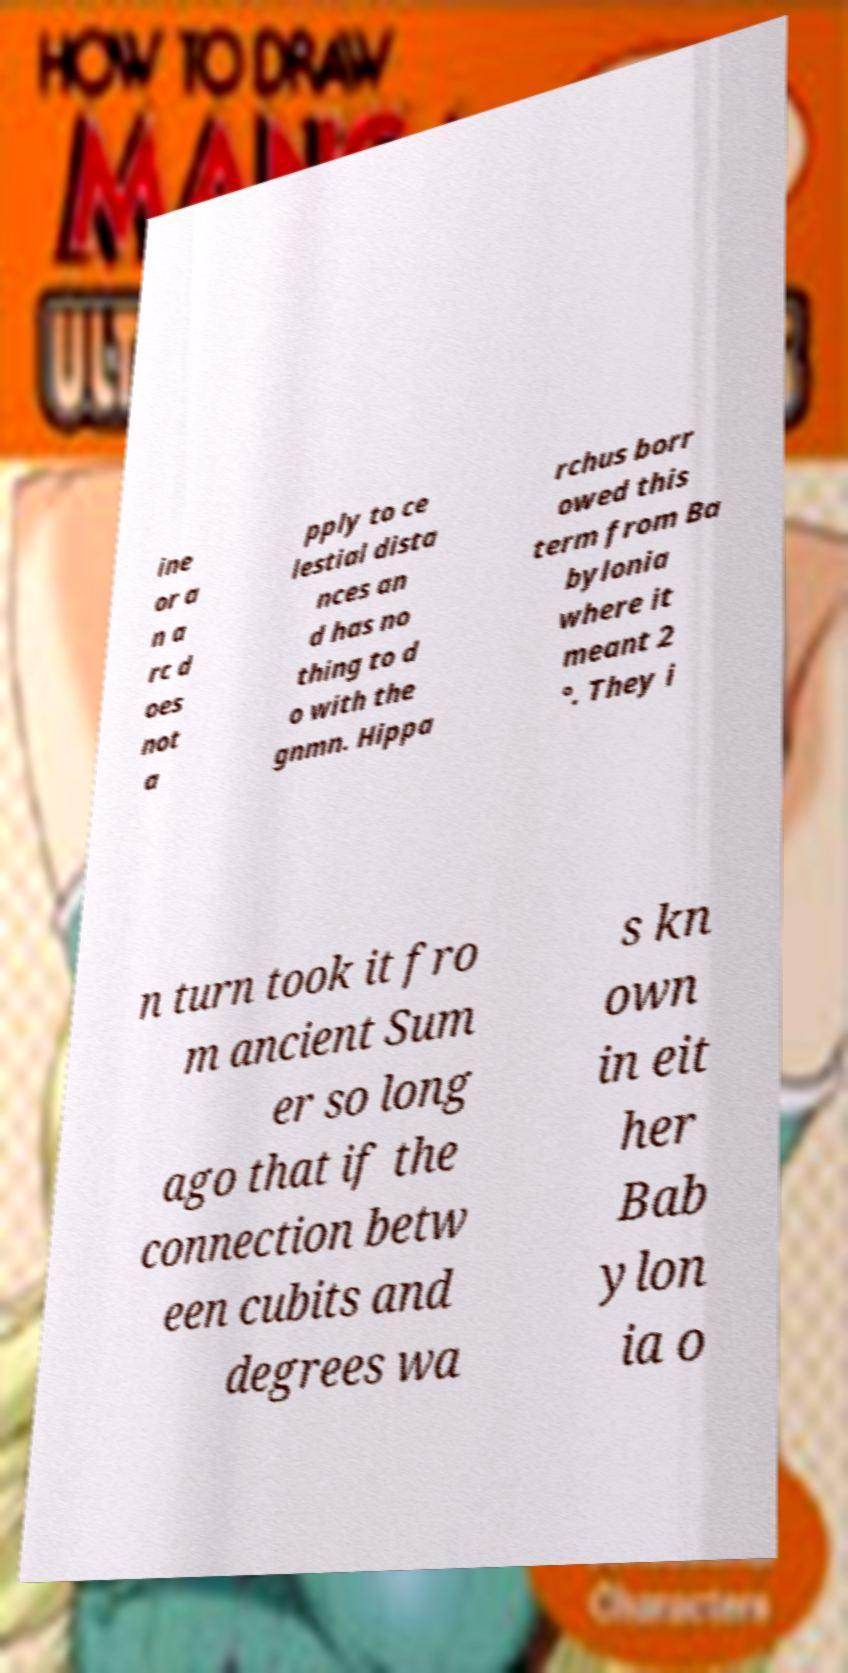Can you accurately transcribe the text from the provided image for me? ine or a n a rc d oes not a pply to ce lestial dista nces an d has no thing to d o with the gnmn. Hippa rchus borr owed this term from Ba bylonia where it meant 2 °. They i n turn took it fro m ancient Sum er so long ago that if the connection betw een cubits and degrees wa s kn own in eit her Bab ylon ia o 